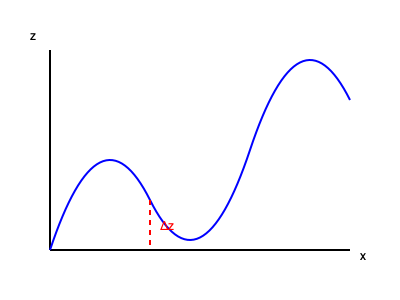An AFM scan of a 2D material on a substrate produces the height profile shown above. If the lateral resolution of the scan is 10 nm/pixel and the vertical resolution is 0.1 nm/pixel, estimate the thickness of the 2D material in nanometers. Assume the step at x = 150 pixels represents the edge of the 2D material. To determine the thickness of the 2D material from the AFM data, we need to follow these steps:

1. Identify the step in the height profile that represents the edge of the 2D material. This is given at x = 150 pixels.

2. Measure the height difference (Δz) at this step. From the graph, we can estimate this to be about 50 pixels in the vertical direction.

3. Convert the pixel measurements to physical dimensions:
   - Vertical resolution: 0.1 nm/pixel
   - Δz in pixels: 50 pixels

4. Calculate the thickness:
   $$ \text{Thickness} = \Delta z \times \text{Vertical resolution} $$
   $$ \text{Thickness} = 50 \text{ pixels} \times 0.1 \text{ nm/pixel} = 5 \text{ nm} $$

Therefore, the estimated thickness of the 2D material is 5 nm.
Answer: 5 nm 